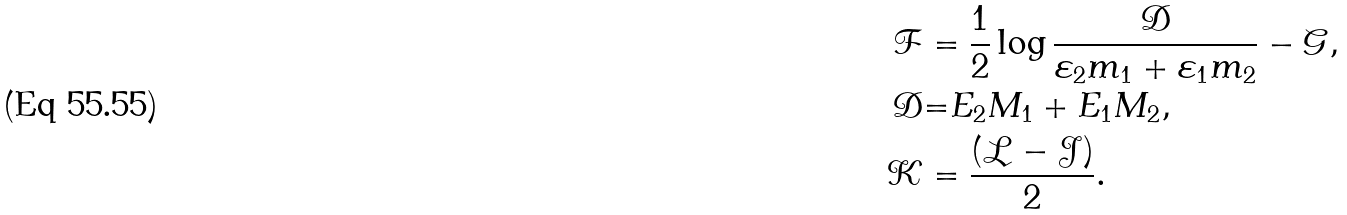Convert formula to latex. <formula><loc_0><loc_0><loc_500><loc_500>\mathcal { F } & = \frac { 1 } { 2 } \log \frac { \mathcal { D } } { \varepsilon _ { 2 } m _ { 1 } + \varepsilon _ { 1 } m _ { 2 } } - \mathcal { G } , \\ \mathcal { D } & \mathcal { = } E _ { 2 } M _ { 1 } + E _ { 1 } M _ { 2 } , \\ \mathcal { K } & = \frac { ( \mathcal { L } - \mathcal { J } ) } { 2 } .</formula> 